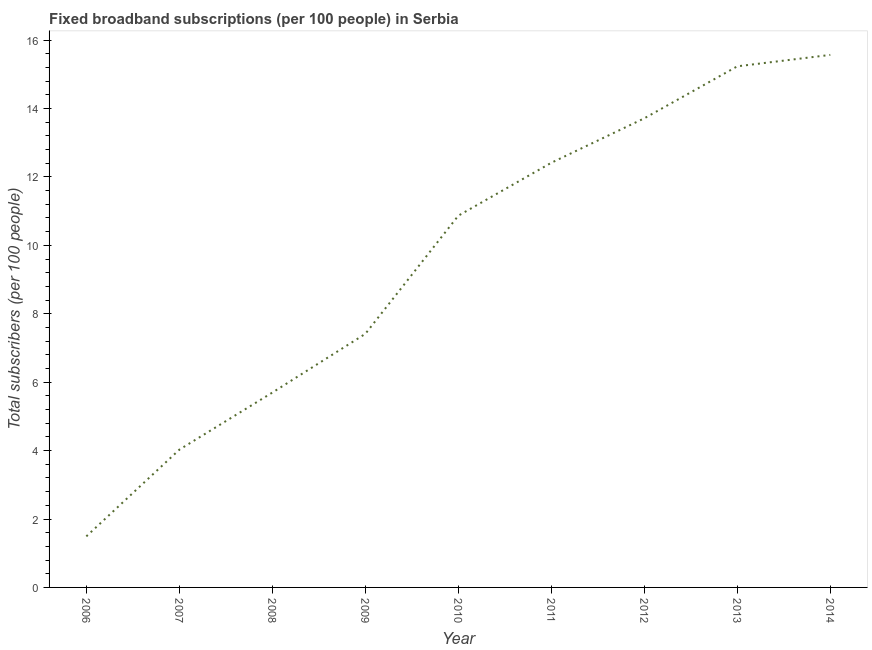What is the total number of fixed broadband subscriptions in 2013?
Provide a succinct answer. 15.23. Across all years, what is the maximum total number of fixed broadband subscriptions?
Keep it short and to the point. 15.57. Across all years, what is the minimum total number of fixed broadband subscriptions?
Make the answer very short. 1.49. In which year was the total number of fixed broadband subscriptions minimum?
Offer a terse response. 2006. What is the sum of the total number of fixed broadband subscriptions?
Give a very brief answer. 86.42. What is the difference between the total number of fixed broadband subscriptions in 2006 and 2013?
Give a very brief answer. -13.74. What is the average total number of fixed broadband subscriptions per year?
Ensure brevity in your answer.  9.6. What is the median total number of fixed broadband subscriptions?
Make the answer very short. 10.87. What is the ratio of the total number of fixed broadband subscriptions in 2006 to that in 2012?
Your answer should be compact. 0.11. What is the difference between the highest and the second highest total number of fixed broadband subscriptions?
Offer a very short reply. 0.33. Is the sum of the total number of fixed broadband subscriptions in 2007 and 2013 greater than the maximum total number of fixed broadband subscriptions across all years?
Your answer should be very brief. Yes. What is the difference between the highest and the lowest total number of fixed broadband subscriptions?
Your response must be concise. 14.07. What is the title of the graph?
Provide a succinct answer. Fixed broadband subscriptions (per 100 people) in Serbia. What is the label or title of the Y-axis?
Make the answer very short. Total subscribers (per 100 people). What is the Total subscribers (per 100 people) of 2006?
Provide a succinct answer. 1.49. What is the Total subscribers (per 100 people) in 2007?
Your response must be concise. 4.03. What is the Total subscribers (per 100 people) in 2008?
Provide a short and direct response. 5.7. What is the Total subscribers (per 100 people) of 2009?
Offer a terse response. 7.41. What is the Total subscribers (per 100 people) in 2010?
Make the answer very short. 10.87. What is the Total subscribers (per 100 people) in 2011?
Provide a succinct answer. 12.41. What is the Total subscribers (per 100 people) in 2012?
Give a very brief answer. 13.71. What is the Total subscribers (per 100 people) of 2013?
Offer a terse response. 15.23. What is the Total subscribers (per 100 people) in 2014?
Offer a terse response. 15.57. What is the difference between the Total subscribers (per 100 people) in 2006 and 2007?
Give a very brief answer. -2.53. What is the difference between the Total subscribers (per 100 people) in 2006 and 2008?
Give a very brief answer. -4.2. What is the difference between the Total subscribers (per 100 people) in 2006 and 2009?
Offer a very short reply. -5.92. What is the difference between the Total subscribers (per 100 people) in 2006 and 2010?
Keep it short and to the point. -9.37. What is the difference between the Total subscribers (per 100 people) in 2006 and 2011?
Your answer should be very brief. -10.92. What is the difference between the Total subscribers (per 100 people) in 2006 and 2012?
Ensure brevity in your answer.  -12.22. What is the difference between the Total subscribers (per 100 people) in 2006 and 2013?
Provide a succinct answer. -13.74. What is the difference between the Total subscribers (per 100 people) in 2006 and 2014?
Keep it short and to the point. -14.07. What is the difference between the Total subscribers (per 100 people) in 2007 and 2008?
Offer a very short reply. -1.67. What is the difference between the Total subscribers (per 100 people) in 2007 and 2009?
Your answer should be very brief. -3.39. What is the difference between the Total subscribers (per 100 people) in 2007 and 2010?
Provide a succinct answer. -6.84. What is the difference between the Total subscribers (per 100 people) in 2007 and 2011?
Provide a short and direct response. -8.39. What is the difference between the Total subscribers (per 100 people) in 2007 and 2012?
Provide a short and direct response. -9.69. What is the difference between the Total subscribers (per 100 people) in 2007 and 2013?
Offer a very short reply. -11.21. What is the difference between the Total subscribers (per 100 people) in 2007 and 2014?
Your response must be concise. -11.54. What is the difference between the Total subscribers (per 100 people) in 2008 and 2009?
Keep it short and to the point. -1.72. What is the difference between the Total subscribers (per 100 people) in 2008 and 2010?
Your response must be concise. -5.17. What is the difference between the Total subscribers (per 100 people) in 2008 and 2011?
Make the answer very short. -6.72. What is the difference between the Total subscribers (per 100 people) in 2008 and 2012?
Your answer should be very brief. -8.02. What is the difference between the Total subscribers (per 100 people) in 2008 and 2013?
Make the answer very short. -9.54. What is the difference between the Total subscribers (per 100 people) in 2008 and 2014?
Provide a short and direct response. -9.87. What is the difference between the Total subscribers (per 100 people) in 2009 and 2010?
Ensure brevity in your answer.  -3.45. What is the difference between the Total subscribers (per 100 people) in 2009 and 2011?
Offer a terse response. -5. What is the difference between the Total subscribers (per 100 people) in 2009 and 2012?
Offer a very short reply. -6.3. What is the difference between the Total subscribers (per 100 people) in 2009 and 2013?
Your answer should be compact. -7.82. What is the difference between the Total subscribers (per 100 people) in 2009 and 2014?
Your response must be concise. -8.15. What is the difference between the Total subscribers (per 100 people) in 2010 and 2011?
Give a very brief answer. -1.55. What is the difference between the Total subscribers (per 100 people) in 2010 and 2012?
Give a very brief answer. -2.85. What is the difference between the Total subscribers (per 100 people) in 2010 and 2013?
Provide a short and direct response. -4.37. What is the difference between the Total subscribers (per 100 people) in 2010 and 2014?
Provide a short and direct response. -4.7. What is the difference between the Total subscribers (per 100 people) in 2011 and 2012?
Keep it short and to the point. -1.3. What is the difference between the Total subscribers (per 100 people) in 2011 and 2013?
Provide a succinct answer. -2.82. What is the difference between the Total subscribers (per 100 people) in 2011 and 2014?
Provide a short and direct response. -3.15. What is the difference between the Total subscribers (per 100 people) in 2012 and 2013?
Provide a short and direct response. -1.52. What is the difference between the Total subscribers (per 100 people) in 2012 and 2014?
Make the answer very short. -1.85. What is the difference between the Total subscribers (per 100 people) in 2013 and 2014?
Your answer should be compact. -0.33. What is the ratio of the Total subscribers (per 100 people) in 2006 to that in 2007?
Offer a terse response. 0.37. What is the ratio of the Total subscribers (per 100 people) in 2006 to that in 2008?
Your response must be concise. 0.26. What is the ratio of the Total subscribers (per 100 people) in 2006 to that in 2009?
Your answer should be very brief. 0.2. What is the ratio of the Total subscribers (per 100 people) in 2006 to that in 2010?
Your answer should be very brief. 0.14. What is the ratio of the Total subscribers (per 100 people) in 2006 to that in 2011?
Your answer should be compact. 0.12. What is the ratio of the Total subscribers (per 100 people) in 2006 to that in 2012?
Ensure brevity in your answer.  0.11. What is the ratio of the Total subscribers (per 100 people) in 2006 to that in 2013?
Your answer should be compact. 0.1. What is the ratio of the Total subscribers (per 100 people) in 2006 to that in 2014?
Keep it short and to the point. 0.1. What is the ratio of the Total subscribers (per 100 people) in 2007 to that in 2008?
Provide a succinct answer. 0.71. What is the ratio of the Total subscribers (per 100 people) in 2007 to that in 2009?
Your answer should be compact. 0.54. What is the ratio of the Total subscribers (per 100 people) in 2007 to that in 2010?
Your response must be concise. 0.37. What is the ratio of the Total subscribers (per 100 people) in 2007 to that in 2011?
Your answer should be compact. 0.32. What is the ratio of the Total subscribers (per 100 people) in 2007 to that in 2012?
Provide a succinct answer. 0.29. What is the ratio of the Total subscribers (per 100 people) in 2007 to that in 2013?
Offer a terse response. 0.26. What is the ratio of the Total subscribers (per 100 people) in 2007 to that in 2014?
Offer a very short reply. 0.26. What is the ratio of the Total subscribers (per 100 people) in 2008 to that in 2009?
Keep it short and to the point. 0.77. What is the ratio of the Total subscribers (per 100 people) in 2008 to that in 2010?
Your answer should be compact. 0.52. What is the ratio of the Total subscribers (per 100 people) in 2008 to that in 2011?
Provide a short and direct response. 0.46. What is the ratio of the Total subscribers (per 100 people) in 2008 to that in 2012?
Your answer should be compact. 0.41. What is the ratio of the Total subscribers (per 100 people) in 2008 to that in 2013?
Your answer should be very brief. 0.37. What is the ratio of the Total subscribers (per 100 people) in 2008 to that in 2014?
Ensure brevity in your answer.  0.37. What is the ratio of the Total subscribers (per 100 people) in 2009 to that in 2010?
Your response must be concise. 0.68. What is the ratio of the Total subscribers (per 100 people) in 2009 to that in 2011?
Your answer should be compact. 0.6. What is the ratio of the Total subscribers (per 100 people) in 2009 to that in 2012?
Give a very brief answer. 0.54. What is the ratio of the Total subscribers (per 100 people) in 2009 to that in 2013?
Give a very brief answer. 0.49. What is the ratio of the Total subscribers (per 100 people) in 2009 to that in 2014?
Provide a short and direct response. 0.48. What is the ratio of the Total subscribers (per 100 people) in 2010 to that in 2011?
Offer a terse response. 0.88. What is the ratio of the Total subscribers (per 100 people) in 2010 to that in 2012?
Keep it short and to the point. 0.79. What is the ratio of the Total subscribers (per 100 people) in 2010 to that in 2013?
Provide a short and direct response. 0.71. What is the ratio of the Total subscribers (per 100 people) in 2010 to that in 2014?
Provide a short and direct response. 0.7. What is the ratio of the Total subscribers (per 100 people) in 2011 to that in 2012?
Ensure brevity in your answer.  0.91. What is the ratio of the Total subscribers (per 100 people) in 2011 to that in 2013?
Provide a succinct answer. 0.81. What is the ratio of the Total subscribers (per 100 people) in 2011 to that in 2014?
Your answer should be compact. 0.8. What is the ratio of the Total subscribers (per 100 people) in 2012 to that in 2014?
Your answer should be compact. 0.88. What is the ratio of the Total subscribers (per 100 people) in 2013 to that in 2014?
Your response must be concise. 0.98. 